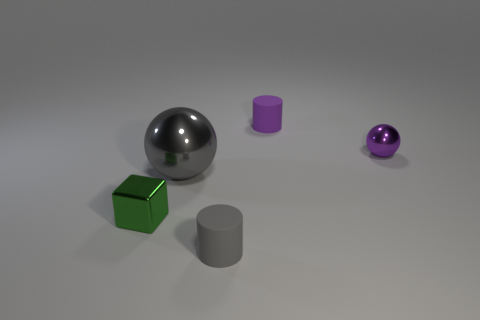Can you tell me more about the green object in the image? Certainly! The green object is a cube with a slightly reflective matte surface. It's positioned on the left side of the scene, oriented with one of its faces almost squarely facing towards the viewer. 